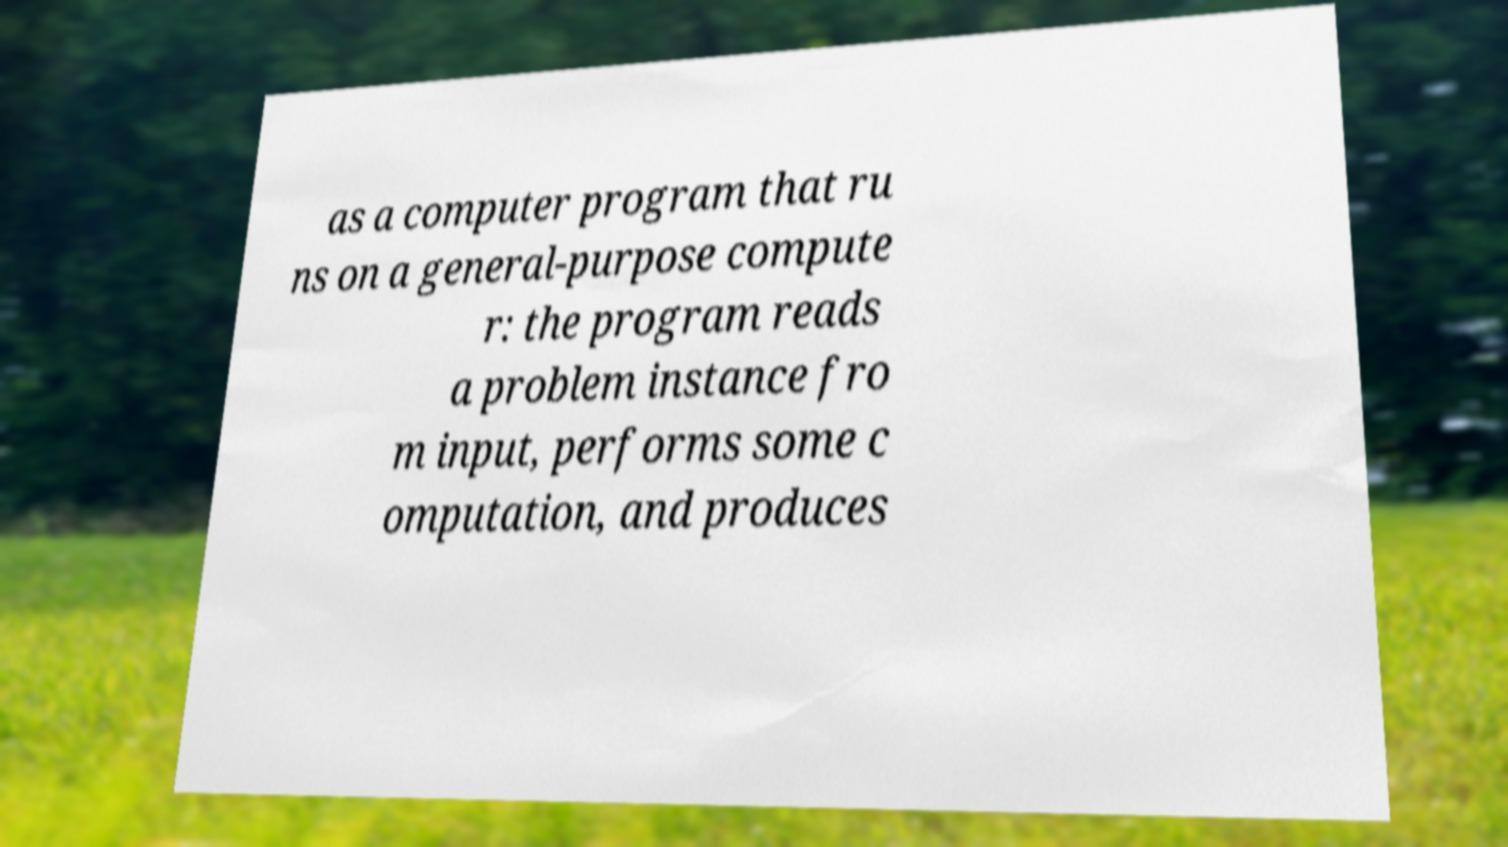Could you extract and type out the text from this image? as a computer program that ru ns on a general-purpose compute r: the program reads a problem instance fro m input, performs some c omputation, and produces 